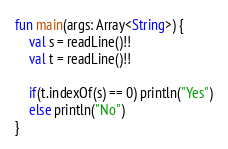Convert code to text. <code><loc_0><loc_0><loc_500><loc_500><_Kotlin_>fun main(args: Array<String>) {
    val s = readLine()!!
    val t = readLine()!!

    if(t.indexOf(s) == 0) println("Yes")
    else println("No")
}
</code> 